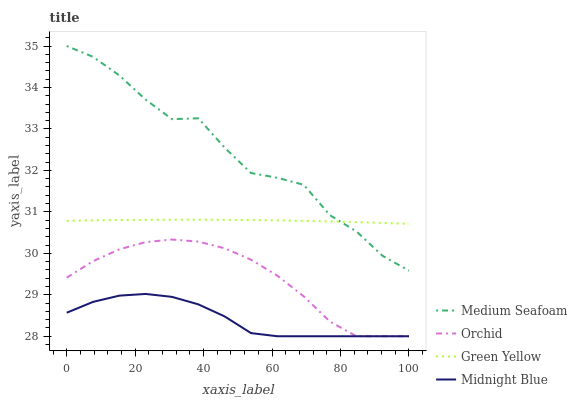Does Green Yellow have the minimum area under the curve?
Answer yes or no. No. Does Green Yellow have the maximum area under the curve?
Answer yes or no. No. Is Medium Seafoam the smoothest?
Answer yes or no. No. Is Green Yellow the roughest?
Answer yes or no. No. Does Medium Seafoam have the lowest value?
Answer yes or no. No. Does Green Yellow have the highest value?
Answer yes or no. No. Is Midnight Blue less than Medium Seafoam?
Answer yes or no. Yes. Is Medium Seafoam greater than Midnight Blue?
Answer yes or no. Yes. Does Midnight Blue intersect Medium Seafoam?
Answer yes or no. No. 